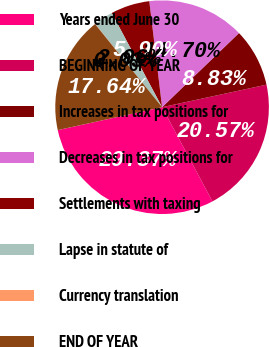Convert chart. <chart><loc_0><loc_0><loc_500><loc_500><pie_chart><fcel>Years ended June 30<fcel>BEGINNING OF YEAR<fcel>Increases in tax positions for<fcel>Decreases in tax positions for<fcel>Settlements with taxing<fcel>Lapse in statute of<fcel>Currency translation<fcel>END OF YEAR<nl><fcel>29.37%<fcel>20.57%<fcel>8.83%<fcel>14.7%<fcel>5.9%<fcel>2.96%<fcel>0.03%<fcel>17.64%<nl></chart> 